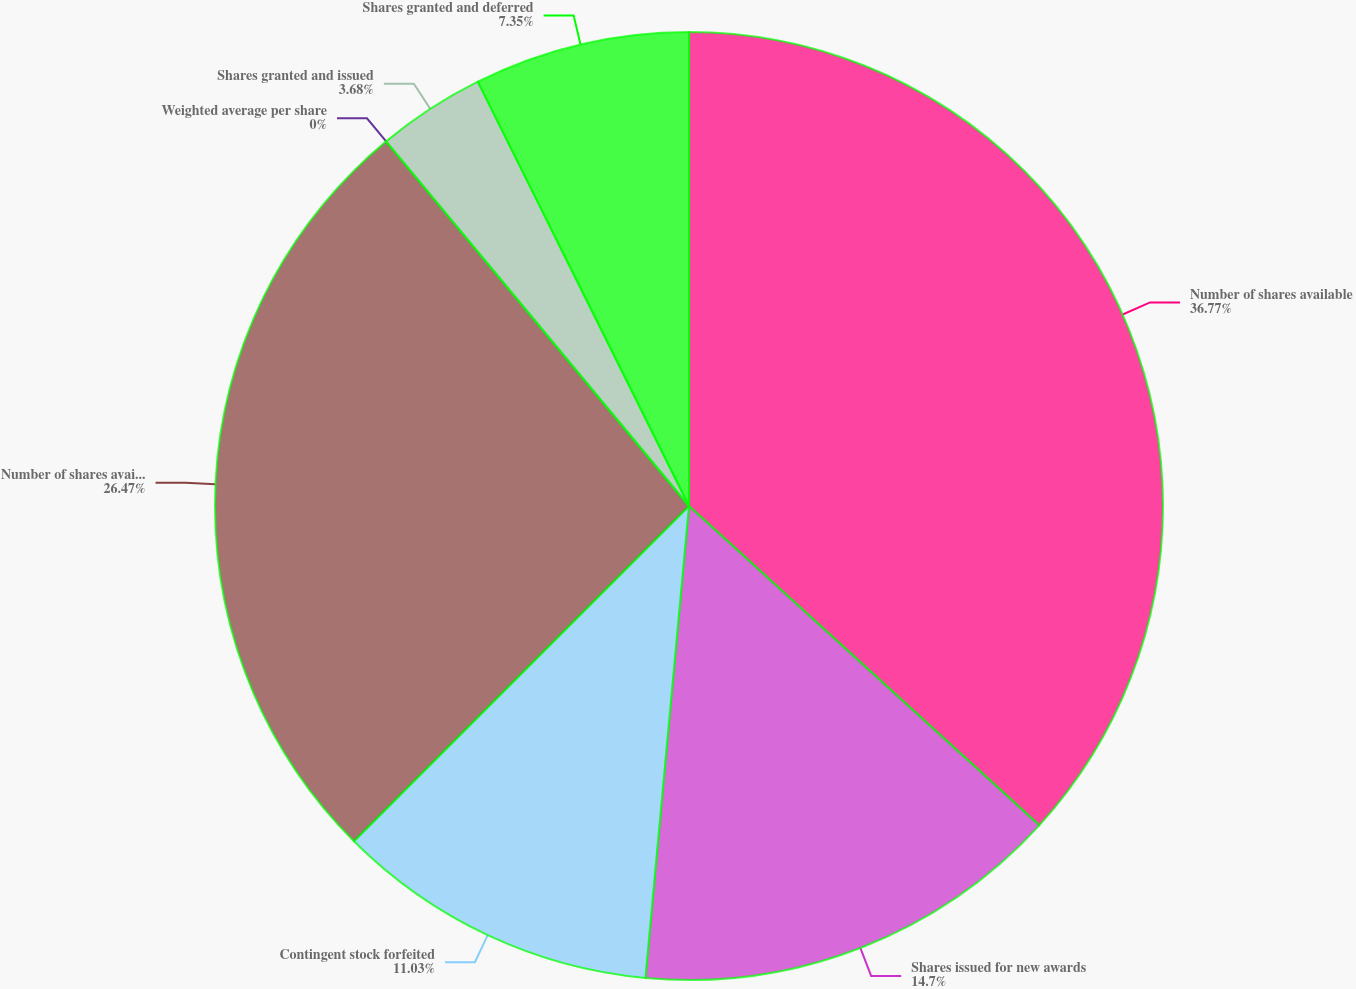<chart> <loc_0><loc_0><loc_500><loc_500><pie_chart><fcel>Number of shares available<fcel>Shares issued for new awards<fcel>Contingent stock forfeited<fcel>Number of shares available end<fcel>Weighted average per share<fcel>Shares granted and issued<fcel>Shares granted and deferred<nl><fcel>36.76%<fcel>14.7%<fcel>11.03%<fcel>26.47%<fcel>0.0%<fcel>3.68%<fcel>7.35%<nl></chart> 